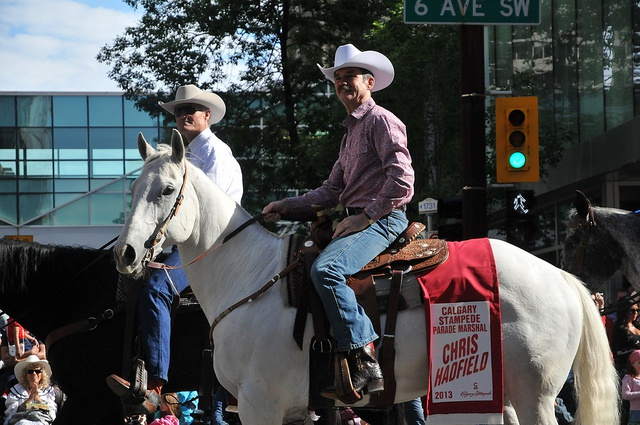Describe the objects in this image and their specific colors. I can see horse in lightblue, gray, black, ivory, and darkgray tones, horse in lightblue, black, gray, darkgray, and maroon tones, people in lightblue, black, gray, and lavender tones, people in lightblue, black, white, gray, and darkgray tones, and horse in lightblue, black, gray, and darkgray tones in this image. 